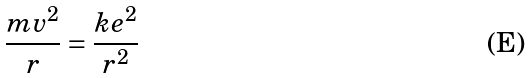<formula> <loc_0><loc_0><loc_500><loc_500>\frac { m v ^ { 2 } } { r } = \frac { k e ^ { 2 } } { r ^ { 2 } }</formula> 